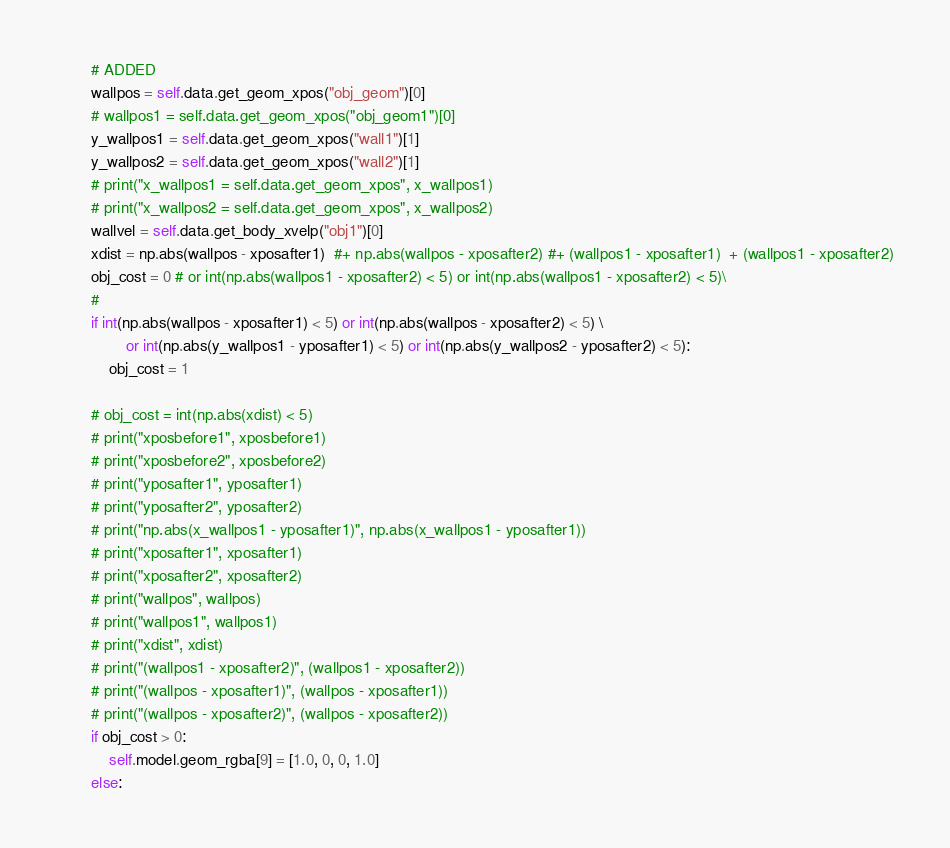<code> <loc_0><loc_0><loc_500><loc_500><_Python_>        # ADDED
        wallpos = self.data.get_geom_xpos("obj_geom")[0]
        # wallpos1 = self.data.get_geom_xpos("obj_geom1")[0]
        y_wallpos1 = self.data.get_geom_xpos("wall1")[1]
        y_wallpos2 = self.data.get_geom_xpos("wall2")[1]
        # print("x_wallpos1 = self.data.get_geom_xpos", x_wallpos1)
        # print("x_wallpos2 = self.data.get_geom_xpos", x_wallpos2)
        wallvel = self.data.get_body_xvelp("obj1")[0]
        xdist = np.abs(wallpos - xposafter1)  #+ np.abs(wallpos - xposafter2) #+ (wallpos1 - xposafter1)  + (wallpos1 - xposafter2)
        obj_cost = 0 # or int(np.abs(wallpos1 - xposafter2) < 5) or int(np.abs(wallpos1 - xposafter2) < 5)\
        #
        if int(np.abs(wallpos - xposafter1) < 5) or int(np.abs(wallpos - xposafter2) < 5) \
                or int(np.abs(y_wallpos1 - yposafter1) < 5) or int(np.abs(y_wallpos2 - yposafter2) < 5):
            obj_cost = 1

        # obj_cost = int(np.abs(xdist) < 5)
        # print("xposbefore1", xposbefore1)
        # print("xposbefore2", xposbefore2)
        # print("yposafter1", yposafter1)
        # print("yposafter2", yposafter2)
        # print("np.abs(x_wallpos1 - yposafter1)", np.abs(x_wallpos1 - yposafter1))
        # print("xposafter1", xposafter1)
        # print("xposafter2", xposafter2)
        # print("wallpos", wallpos)
        # print("wallpos1", wallpos1)
        # print("xdist", xdist)
        # print("(wallpos1 - xposafter2)", (wallpos1 - xposafter2))
        # print("(wallpos - xposafter1)", (wallpos - xposafter1))
        # print("(wallpos - xposafter2)", (wallpos - xposafter2))
        if obj_cost > 0:
            self.model.geom_rgba[9] = [1.0, 0, 0, 1.0]
        else:</code> 